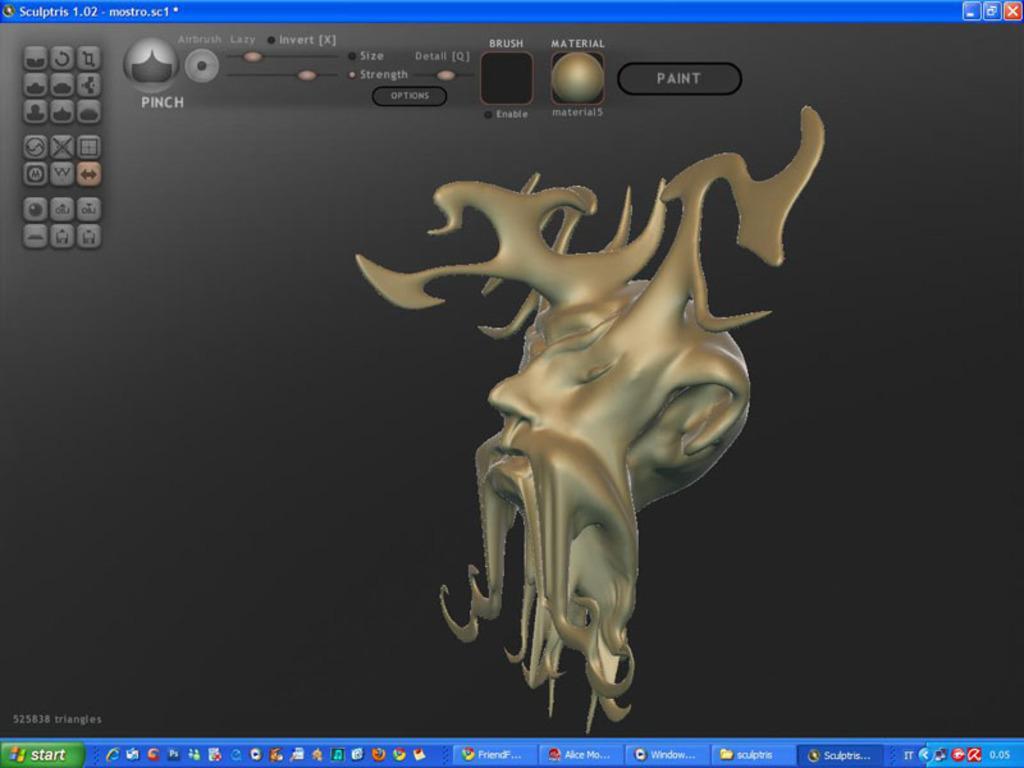How would you summarize this image in a sentence or two? In this image we can see a screen with icons and an image. 